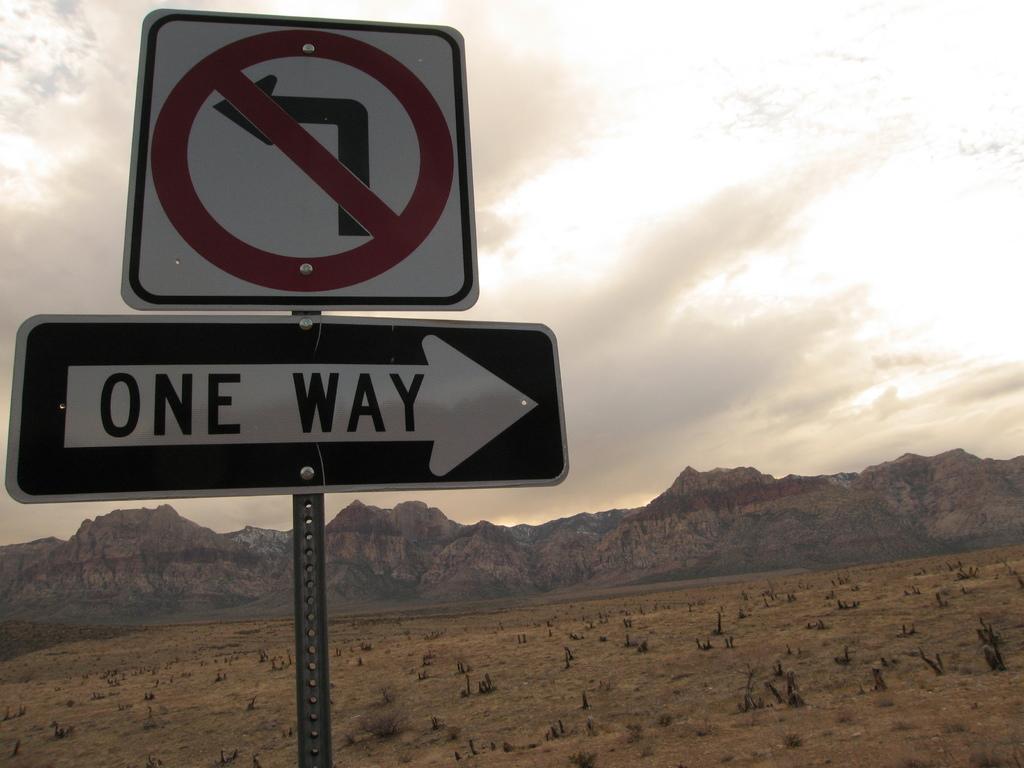How many different ways can you go?
Give a very brief answer. One. 